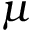<formula> <loc_0><loc_0><loc_500><loc_500>\mu</formula> 